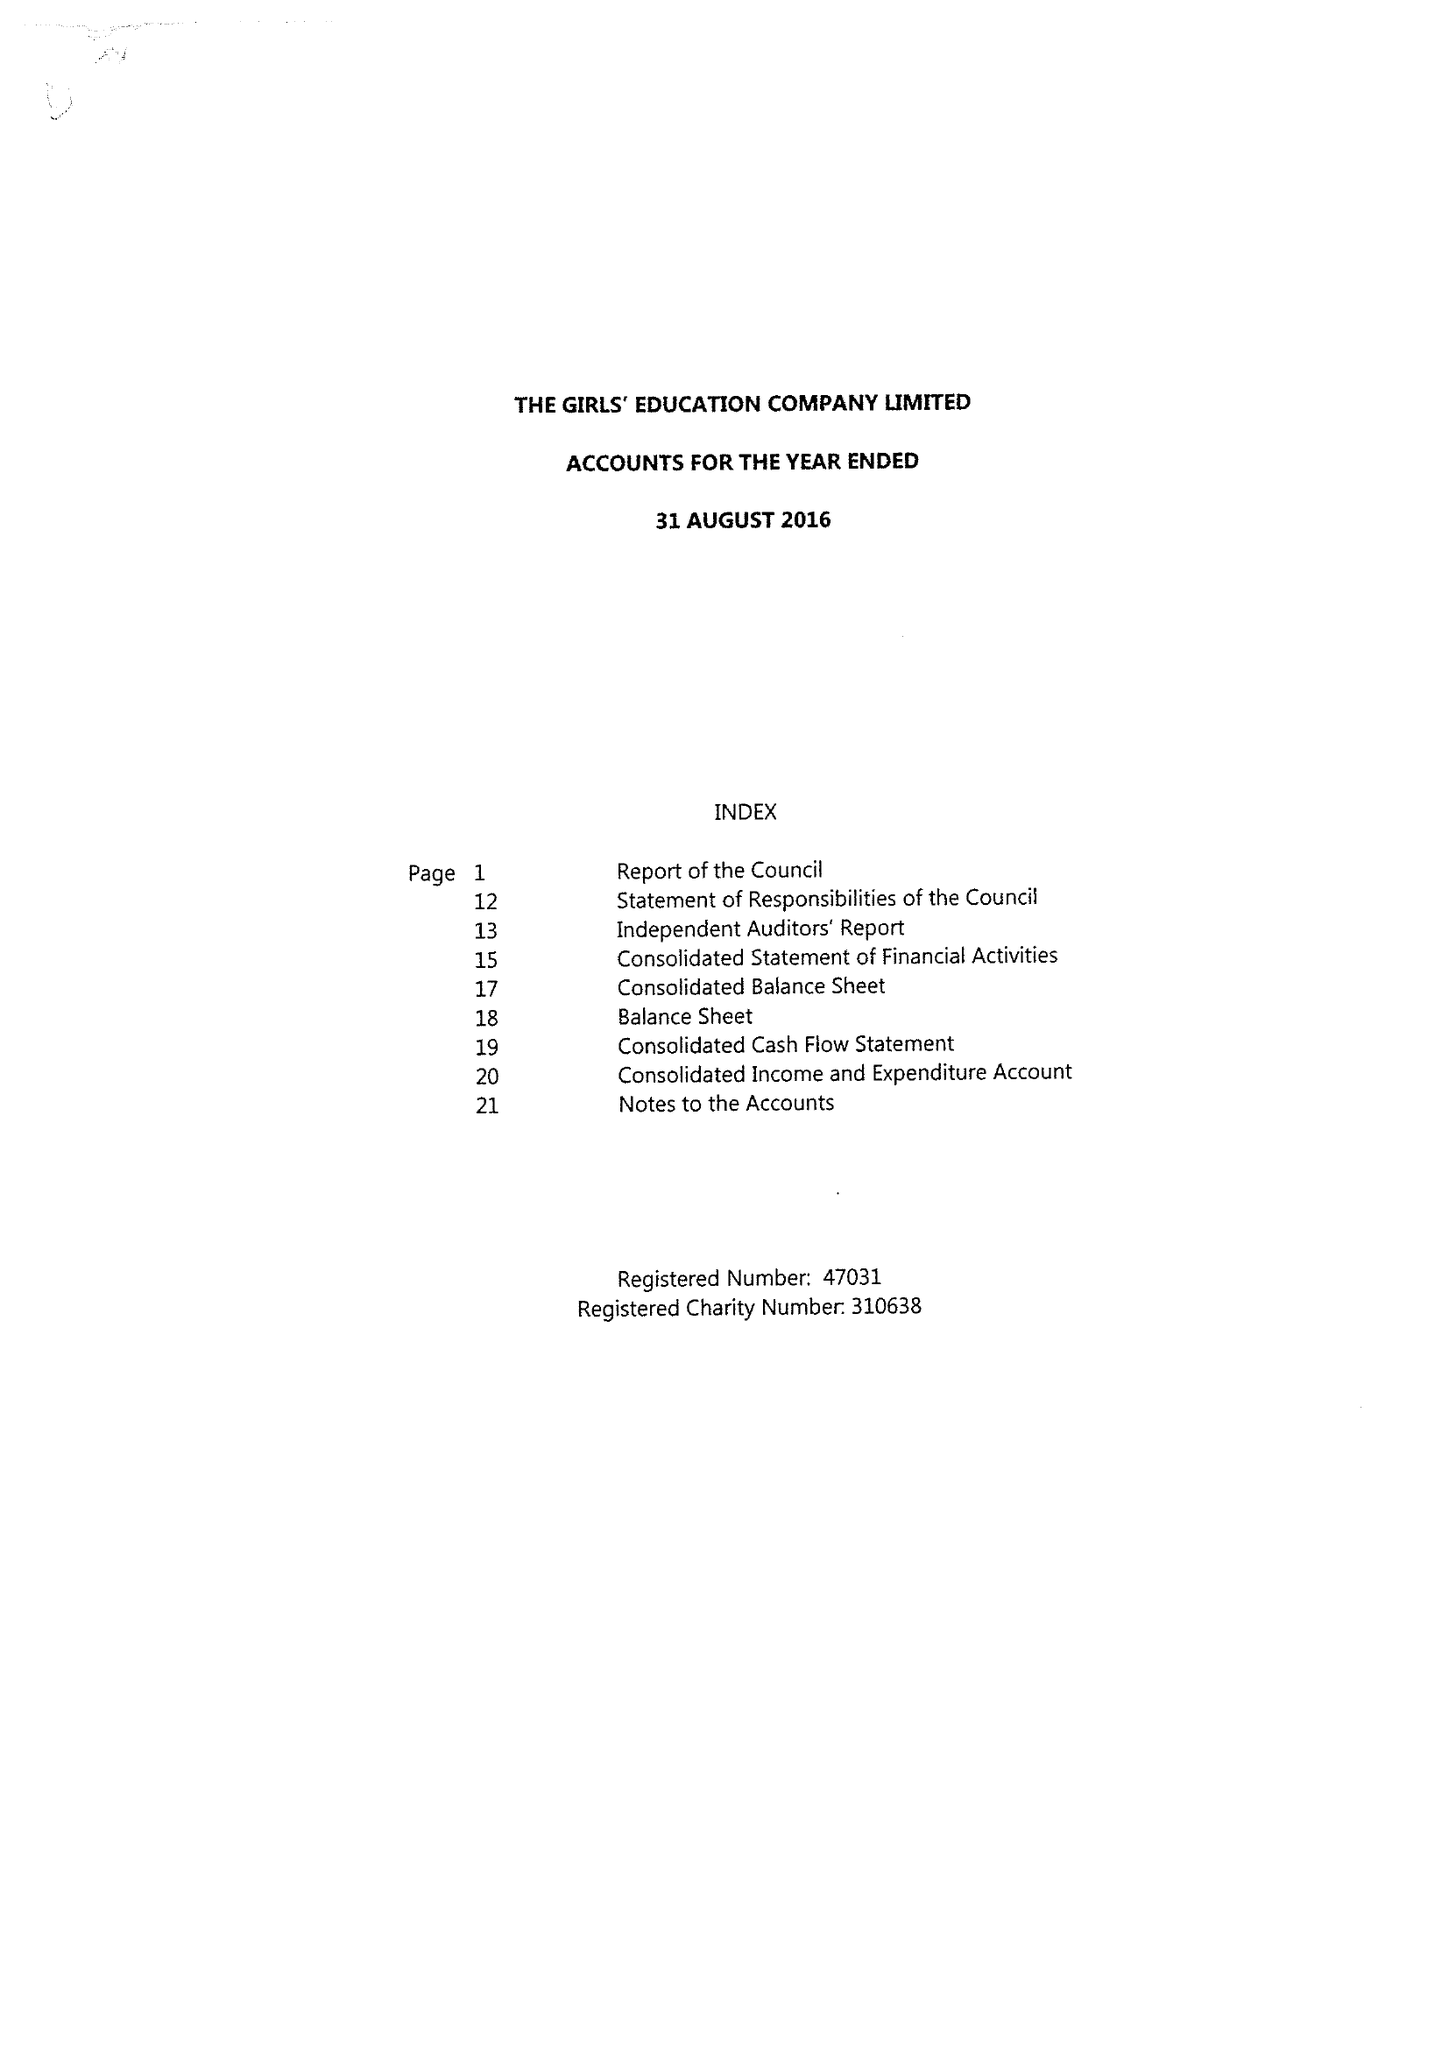What is the value for the charity_number?
Answer the question using a single word or phrase. 310638 